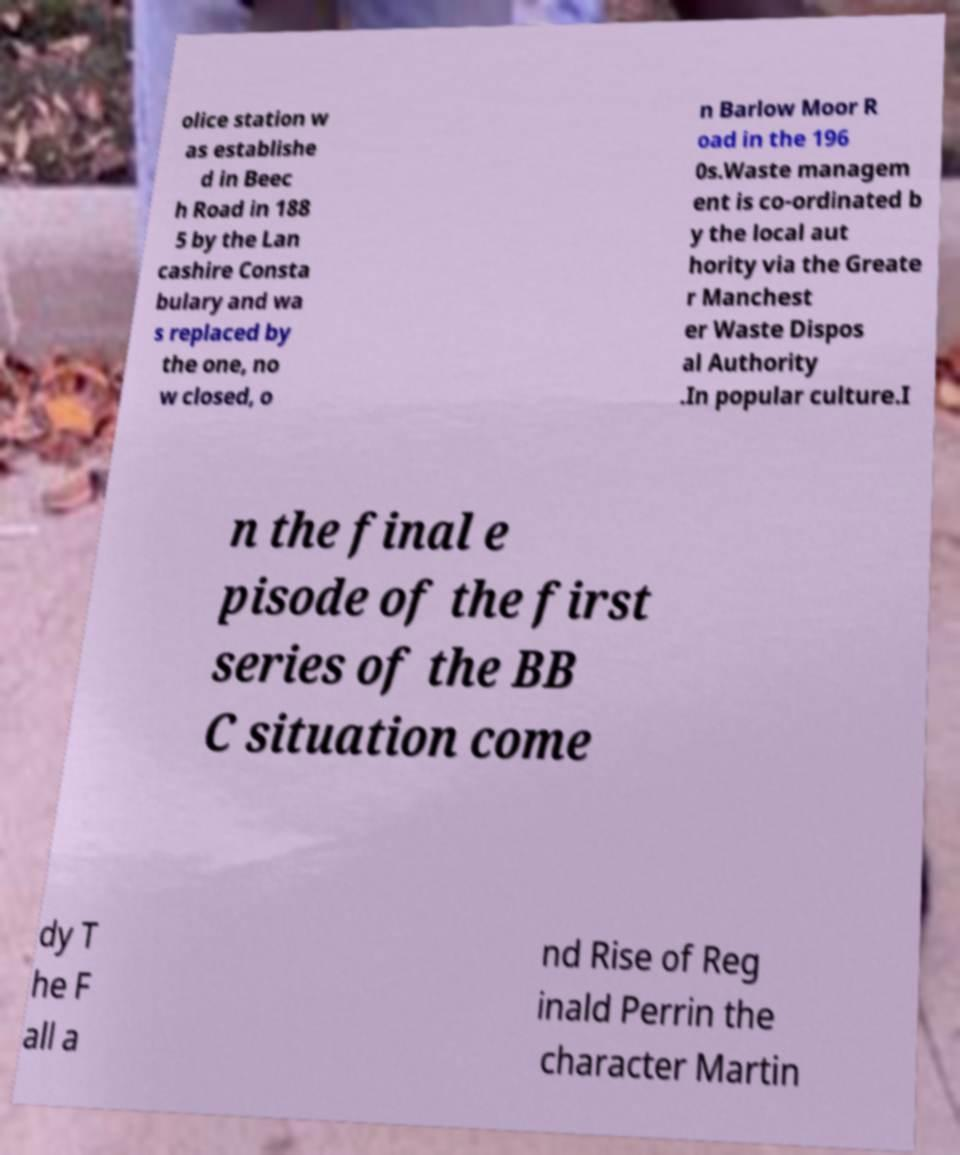Can you read and provide the text displayed in the image?This photo seems to have some interesting text. Can you extract and type it out for me? olice station w as establishe d in Beec h Road in 188 5 by the Lan cashire Consta bulary and wa s replaced by the one, no w closed, o n Barlow Moor R oad in the 196 0s.Waste managem ent is co-ordinated b y the local aut hority via the Greate r Manchest er Waste Dispos al Authority .In popular culture.I n the final e pisode of the first series of the BB C situation come dy T he F all a nd Rise of Reg inald Perrin the character Martin 